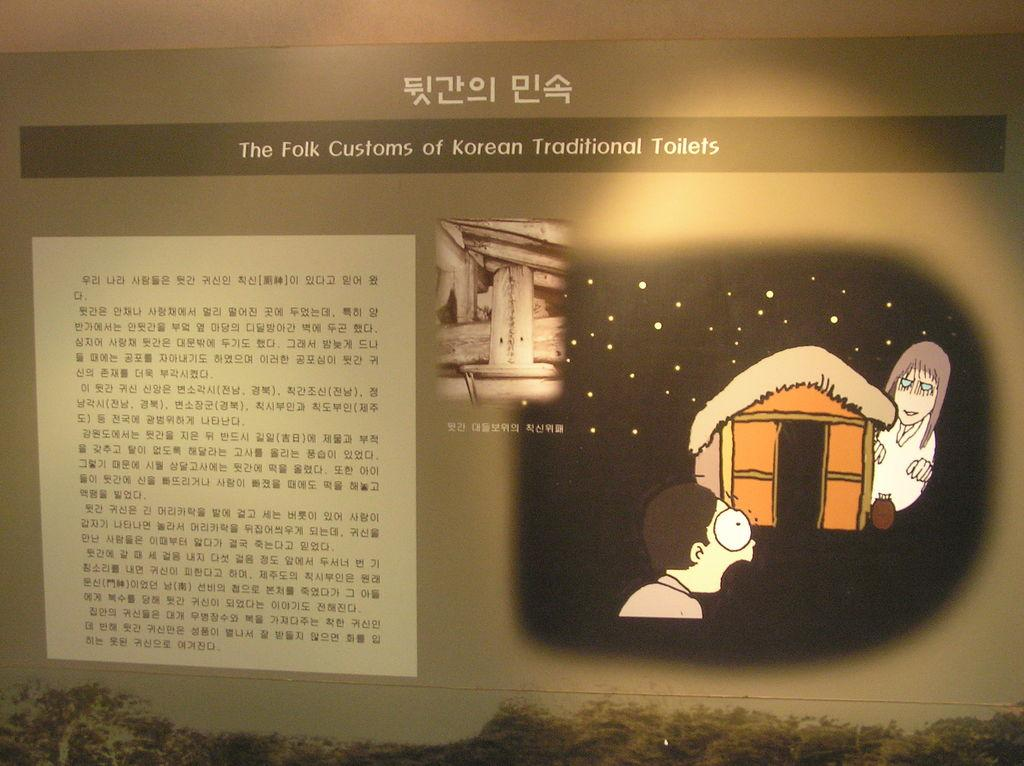<image>
Write a terse but informative summary of the picture. A display shows text and a picture on the right with the title pertaining to the customs of Korean toilets above. 